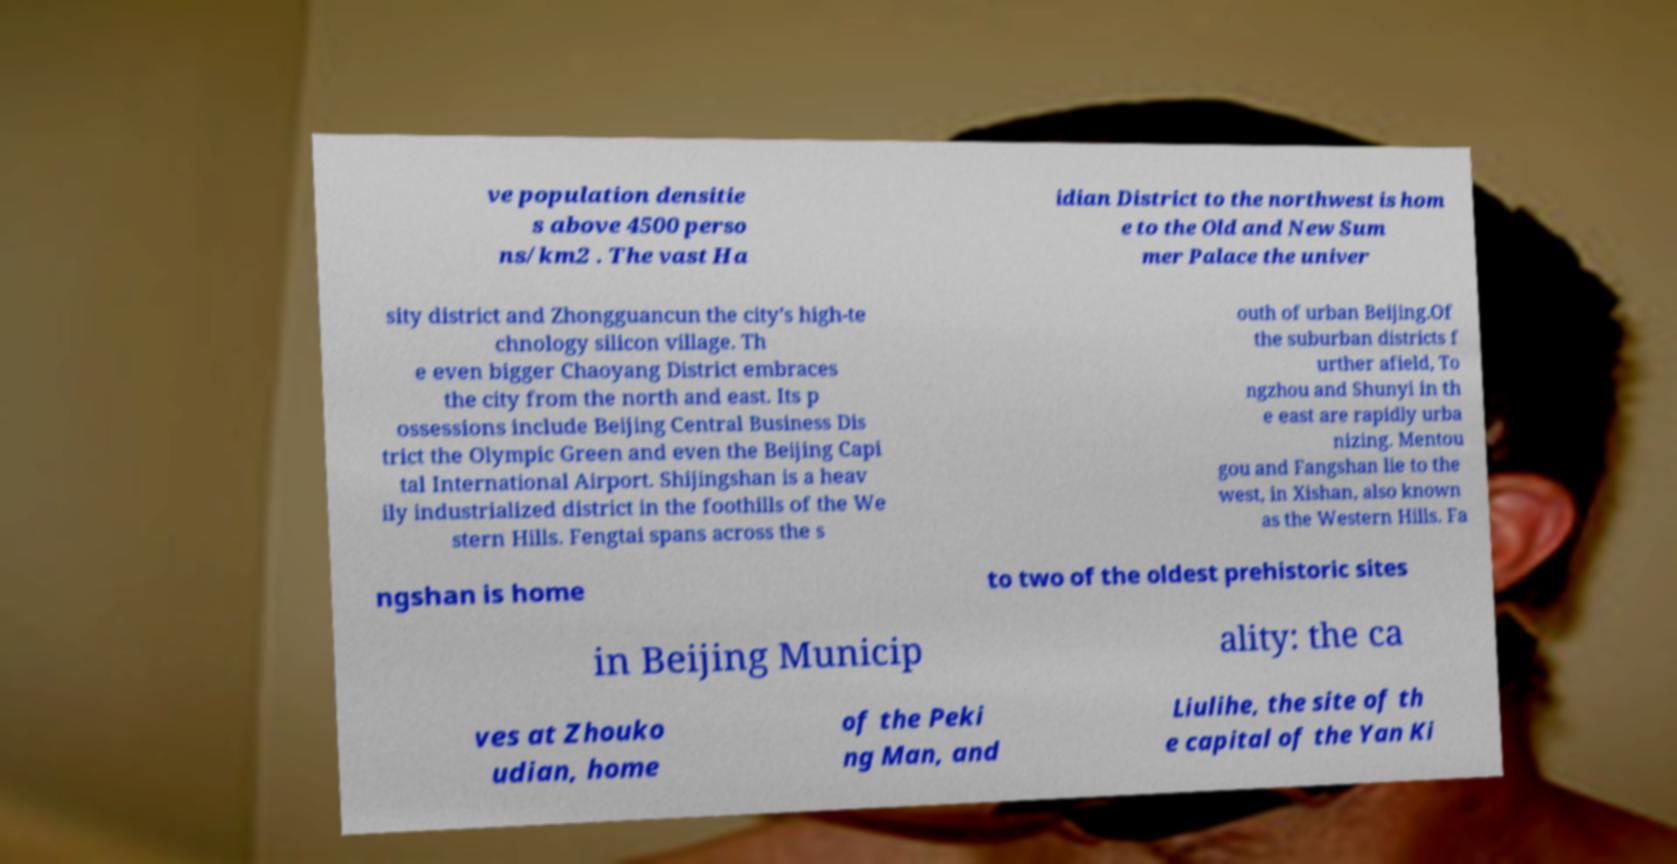For documentation purposes, I need the text within this image transcribed. Could you provide that? ve population densitie s above 4500 perso ns/km2 . The vast Ha idian District to the northwest is hom e to the Old and New Sum mer Palace the univer sity district and Zhongguancun the city’s high-te chnology silicon village. Th e even bigger Chaoyang District embraces the city from the north and east. Its p ossessions include Beijing Central Business Dis trict the Olympic Green and even the Beijing Capi tal International Airport. Shijingshan is a heav ily industrialized district in the foothills of the We stern Hills. Fengtai spans across the s outh of urban Beijing.Of the suburban districts f urther afield, To ngzhou and Shunyi in th e east are rapidly urba nizing. Mentou gou and Fangshan lie to the west, in Xishan, also known as the Western Hills. Fa ngshan is home to two of the oldest prehistoric sites in Beijing Municip ality: the ca ves at Zhouko udian, home of the Peki ng Man, and Liulihe, the site of th e capital of the Yan Ki 